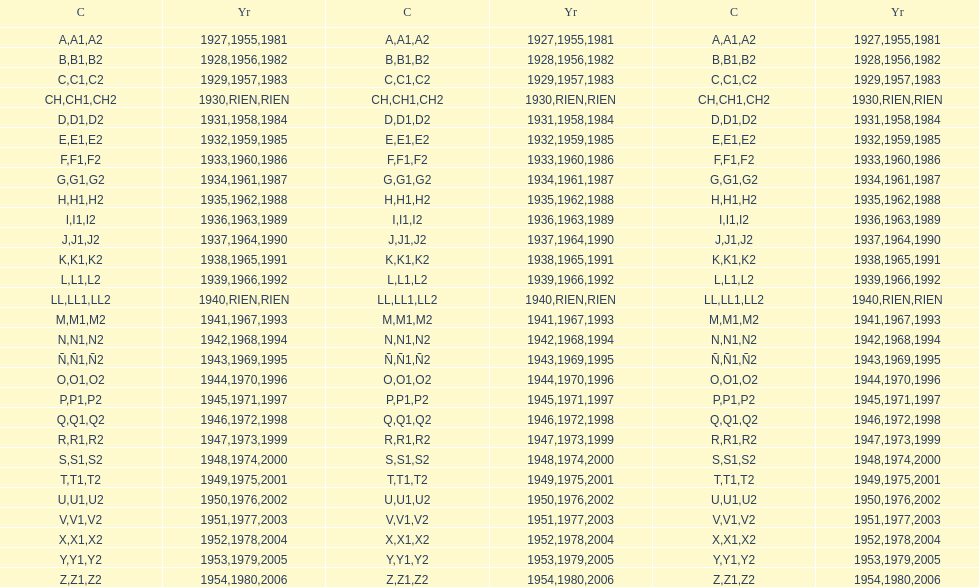What was the only year to use the code ch? 1930. 